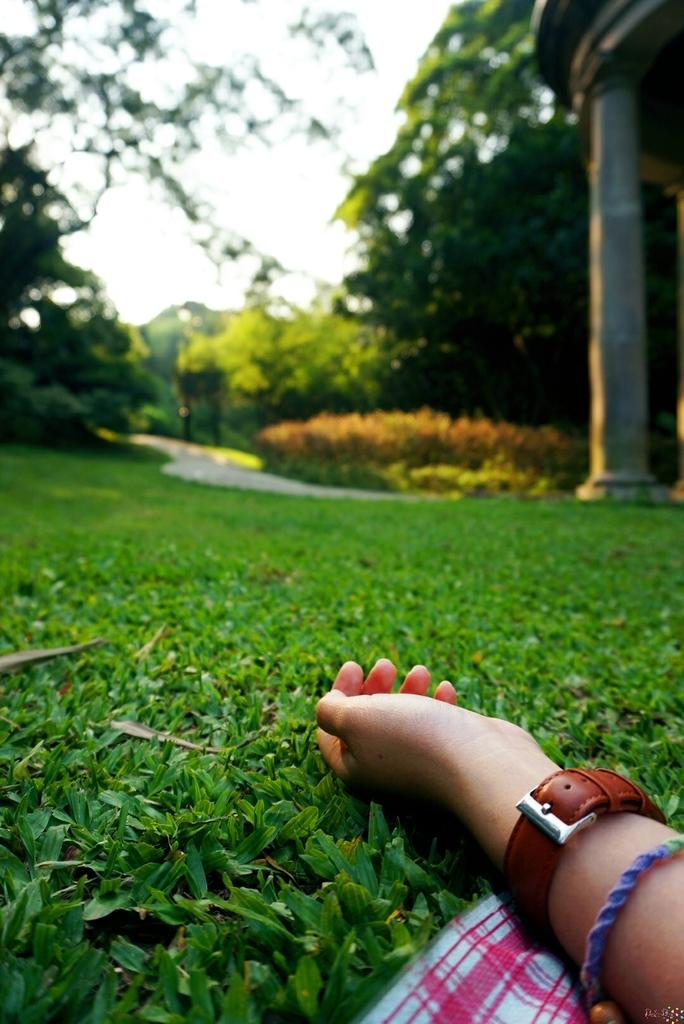What part of the human body is visible in the image? There is a human hand in the image. What type of vegetation can be seen in the image? There is grass and plants visible in the image. What can be seen in the background of the image? There are trees in the background of the image. What is visible at the top of the image? The sky is visible at the top of the image. How many screws can be seen in the image? There are no screws present in the image. 